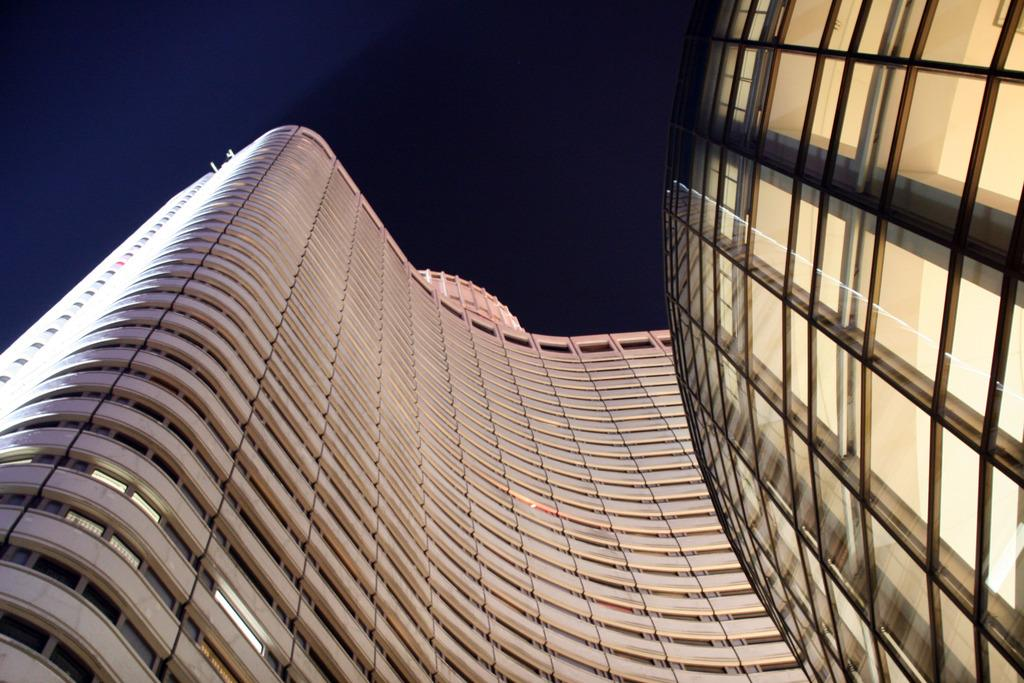What type of structures can be seen in the image? There are buildings in the image. What can be observed illuminating the scene in the image? There are lights visible in the image. How many hands are visible in the image? There are no hands visible in the image; it only features buildings and lights. 